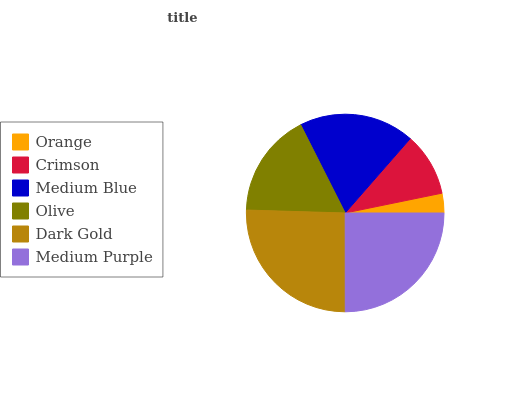Is Orange the minimum?
Answer yes or no. Yes. Is Dark Gold the maximum?
Answer yes or no. Yes. Is Crimson the minimum?
Answer yes or no. No. Is Crimson the maximum?
Answer yes or no. No. Is Crimson greater than Orange?
Answer yes or no. Yes. Is Orange less than Crimson?
Answer yes or no. Yes. Is Orange greater than Crimson?
Answer yes or no. No. Is Crimson less than Orange?
Answer yes or no. No. Is Medium Blue the high median?
Answer yes or no. Yes. Is Olive the low median?
Answer yes or no. Yes. Is Orange the high median?
Answer yes or no. No. Is Dark Gold the low median?
Answer yes or no. No. 